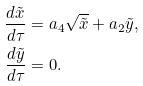Convert formula to latex. <formula><loc_0><loc_0><loc_500><loc_500>\frac { d \tilde { x } } { d \tau } & = a _ { 4 } \sqrt { \tilde { x } } + a _ { 2 } \tilde { y } , \\ \frac { d \tilde { y } } { d \tau } & = 0 .</formula> 